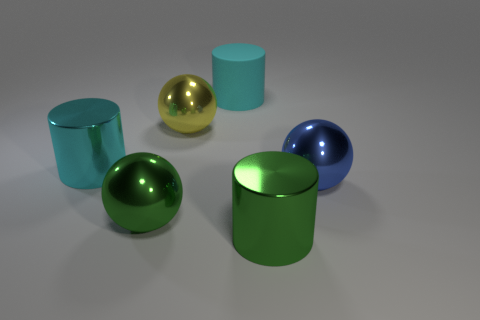There is a cylinder left of the matte cylinder; is it the same size as the green thing that is behind the green metallic cylinder?
Keep it short and to the point. Yes. What is the size of the cyan cylinder that is in front of the cyan object behind the cyan metal cylinder?
Your response must be concise. Large. There is a big cylinder that is both behind the blue shiny sphere and in front of the matte object; what material is it?
Ensure brevity in your answer.  Metal. The rubber cylinder is what color?
Provide a succinct answer. Cyan. There is a cyan object to the left of the big rubber thing; what shape is it?
Your answer should be compact. Cylinder. Is there a blue metallic ball that is left of the sphere that is right of the shiny cylinder in front of the cyan shiny object?
Keep it short and to the point. No. Is there any other thing that has the same shape as the cyan metallic thing?
Keep it short and to the point. Yes. Are there any big purple cubes?
Your answer should be compact. No. Does the big cyan object that is on the right side of the large yellow ball have the same material as the big cyan cylinder that is left of the large cyan rubber cylinder?
Offer a terse response. No. How big is the green thing that is behind the big green object that is right of the large cyan cylinder to the right of the green sphere?
Ensure brevity in your answer.  Large. 